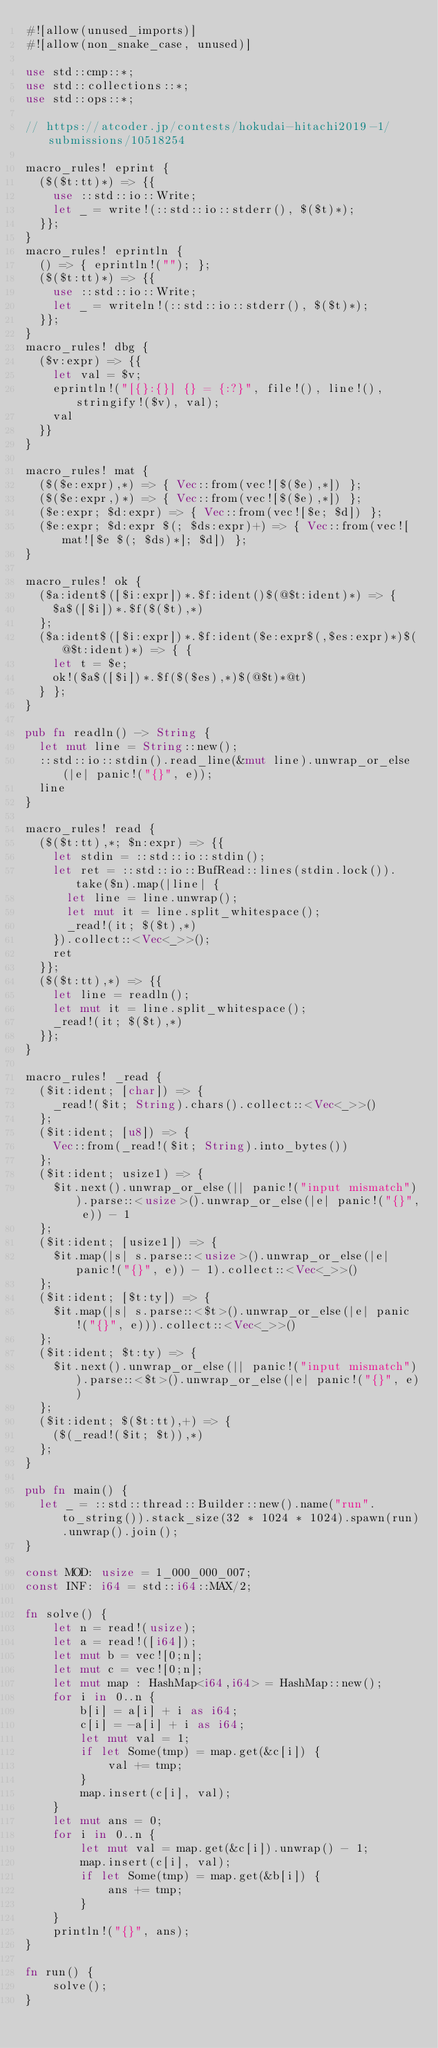Convert code to text. <code><loc_0><loc_0><loc_500><loc_500><_Rust_>#![allow(unused_imports)]
#![allow(non_snake_case, unused)]

use std::cmp::*;
use std::collections::*;
use std::ops::*;

// https://atcoder.jp/contests/hokudai-hitachi2019-1/submissions/10518254

macro_rules! eprint {
	($($t:tt)*) => {{
		use ::std::io::Write;
		let _ = write!(::std::io::stderr(), $($t)*);
	}};
}
macro_rules! eprintln {
	() => { eprintln!(""); };
	($($t:tt)*) => {{
		use ::std::io::Write;
		let _ = writeln!(::std::io::stderr(), $($t)*);
	}};
}
macro_rules! dbg {
	($v:expr) => {{
		let val = $v;
		eprintln!("[{}:{}] {} = {:?}", file!(), line!(), stringify!($v), val);
		val
	}}
}

macro_rules! mat {
	($($e:expr),*) => { Vec::from(vec![$($e),*]) };
	($($e:expr,)*) => { Vec::from(vec![$($e),*]) };
	($e:expr; $d:expr) => { Vec::from(vec![$e; $d]) };
	($e:expr; $d:expr $(; $ds:expr)+) => { Vec::from(vec![mat![$e $(; $ds)*]; $d]) };
}

macro_rules! ok {
	($a:ident$([$i:expr])*.$f:ident()$(@$t:ident)*) => {
		$a$([$i])*.$f($($t),*)
	};
	($a:ident$([$i:expr])*.$f:ident($e:expr$(,$es:expr)*)$(@$t:ident)*) => { {
		let t = $e;
		ok!($a$([$i])*.$f($($es),*)$(@$t)*@t)
	} };
}

pub fn readln() -> String {
	let mut line = String::new();
	::std::io::stdin().read_line(&mut line).unwrap_or_else(|e| panic!("{}", e));
	line
}

macro_rules! read {
	($($t:tt),*; $n:expr) => {{
		let stdin = ::std::io::stdin();
		let ret = ::std::io::BufRead::lines(stdin.lock()).take($n).map(|line| {
			let line = line.unwrap();
			let mut it = line.split_whitespace();
			_read!(it; $($t),*)
		}).collect::<Vec<_>>();
		ret
	}};
	($($t:tt),*) => {{
		let line = readln();
		let mut it = line.split_whitespace();
		_read!(it; $($t),*)
	}};
}

macro_rules! _read {
	($it:ident; [char]) => {
		_read!($it; String).chars().collect::<Vec<_>>()
	};
	($it:ident; [u8]) => {
		Vec::from(_read!($it; String).into_bytes())
	};
	($it:ident; usize1) => {
		$it.next().unwrap_or_else(|| panic!("input mismatch")).parse::<usize>().unwrap_or_else(|e| panic!("{}", e)) - 1
	};
	($it:ident; [usize1]) => {
		$it.map(|s| s.parse::<usize>().unwrap_or_else(|e| panic!("{}", e)) - 1).collect::<Vec<_>>()
	};
	($it:ident; [$t:ty]) => {
		$it.map(|s| s.parse::<$t>().unwrap_or_else(|e| panic!("{}", e))).collect::<Vec<_>>()
	};
	($it:ident; $t:ty) => {
		$it.next().unwrap_or_else(|| panic!("input mismatch")).parse::<$t>().unwrap_or_else(|e| panic!("{}", e))
	};
	($it:ident; $($t:tt),+) => {
		($(_read!($it; $t)),*)
	};
}

pub fn main() {
	let _ = ::std::thread::Builder::new().name("run".to_string()).stack_size(32 * 1024 * 1024).spawn(run).unwrap().join();
}

const MOD: usize = 1_000_000_007;
const INF: i64 = std::i64::MAX/2;

fn solve() {
    let n = read!(usize);
    let a = read!([i64]);
    let mut b = vec![0;n];
    let mut c = vec![0;n];
    let mut map : HashMap<i64,i64> = HashMap::new();
    for i in 0..n {
        b[i] = a[i] + i as i64;
        c[i] = -a[i] + i as i64;
        let mut val = 1;
        if let Some(tmp) = map.get(&c[i]) {
            val += tmp;
        }
        map.insert(c[i], val);
    }
    let mut ans = 0;
    for i in 0..n {
        let mut val = map.get(&c[i]).unwrap() - 1;
        map.insert(c[i], val);
        if let Some(tmp) = map.get(&b[i]) {
            ans += tmp;
        }
    }
    println!("{}", ans);
}

fn run() {
    solve();
}
</code> 